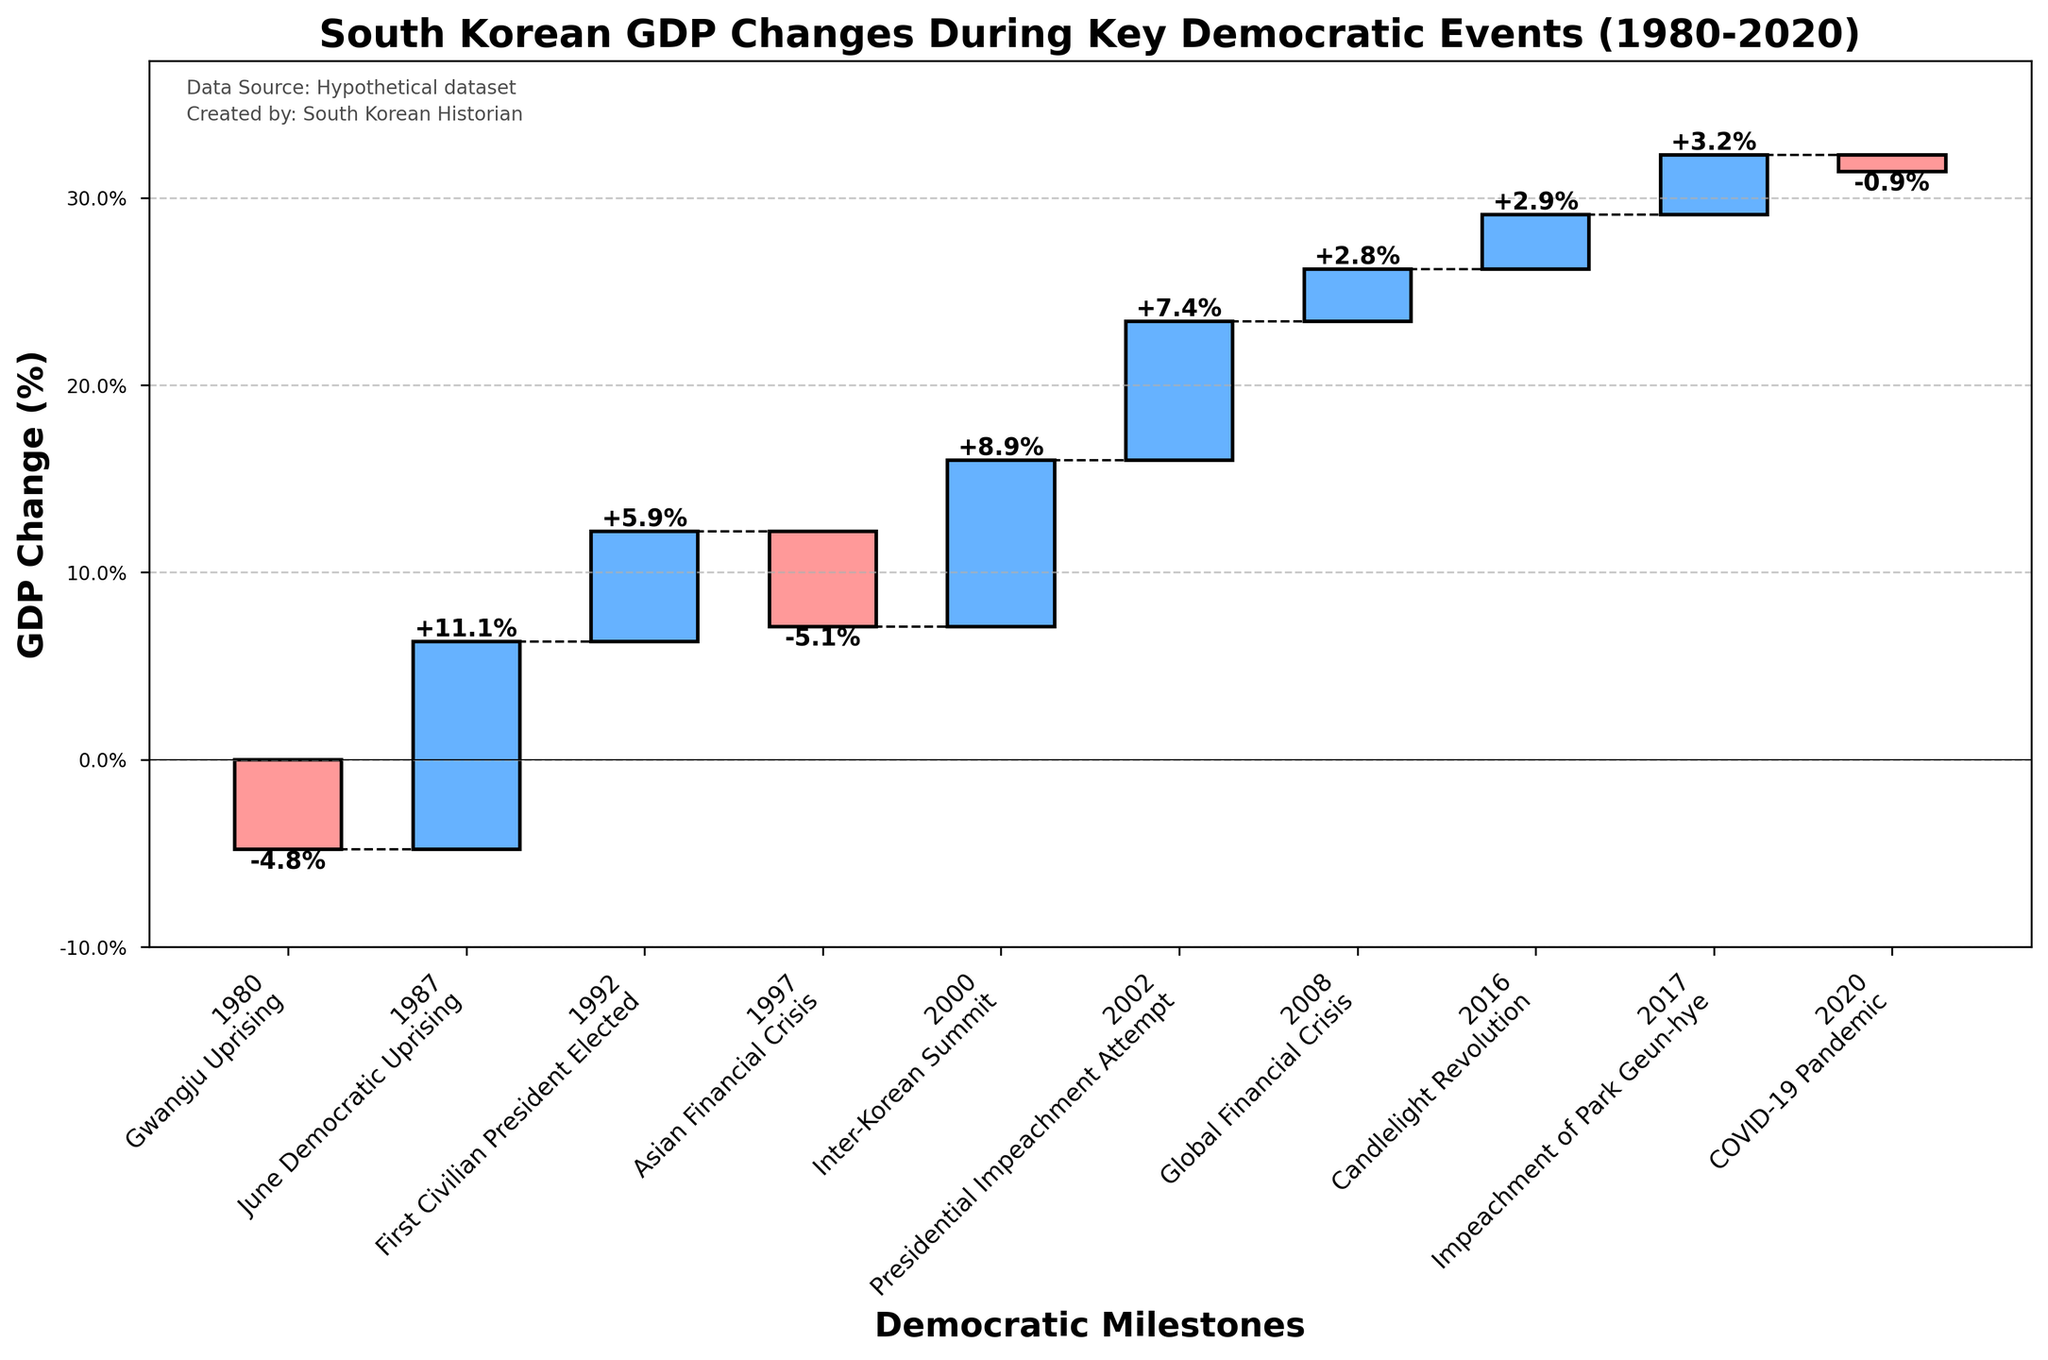What is the title of the figure? The title is located at the top of the figure and specifies what the chart represents. In this case, it reads "South Korean GDP Changes During Key Democratic Events (1980-2020)."
Answer: South Korean GDP Changes During Key Democratic Events (1980-2020) How many key democratic events are depicted in the figure? The number of bars in the chart corresponds to the number of events. Each bar represents a unique event, and by counting the bars, we can determine the number. There are 10 events shown.
Answer: 10 Which event resulted in the largest positive GDP change? By comparing the heights of the blue bars, the event with the largest positive change is the one with the tallest blue bar. The June Democratic Uprising in 1987 shows the highest positive change of 11.1%.
Answer: June Democratic Uprising, 1987 Which event resulted in the largest negative GDP change? By comparing the heights of the red bars, the event with the largest negative change is the one with the tallest red bar. The Asian Financial Crisis in 1997 shows the largest negative change of -5.1%.
Answer: Asian Financial Crisis, 1997 What was the cumulative GDP change by the year 2000? The cumulative GDP change is calculated by summing all preceding changes. By the year 2000, the cumulative change is (-4.8 + 11.1 + 5.9 - 5.1 + 8.9).
Answer: 16 How did the GDP change during the 2008 Global Financial Crisis compare to the 2020 COVID-19 Pandemic? To compare the changes, look at the heights of the bars for these two events. The 2008 Global Financial Crisis had a GDP change of 2.8%, while the 2020 COVID-19 Pandemic had a GDP change of -0.9%. The GDP increased during the 2008 crisis, whereas it decreased during the 2020 pandemic.
Answer: 2008: +2.8%, 2020: -0.9% What is the difference in GDP change between the first civilian president elected in 1992 and the Candlelight Revolution in 2016? Subtract the GDP change in 2016 from that in 1992. The values are 5.9% for 1992 and 2.9% for 2016. The difference is 5.9% - 2.9%.
Answer: 3.0% What is the average GDP change during the events in the 1990s? Identify the events in the 1990s (1992 and 1997) and average their GDP changes. The changes are 5.9% and -5.1%. Average = (5.9 + (-5.1))/2.
Answer: 0.4% Which events marked a negative GDP change? Identify and list the events with red bars. These events are the Gwangju Uprising (1980), Asian Financial Crisis (1997), and COVID-19 Pandemic (2020).
Answer: Gwangju Uprising, Asian Financial Crisis, COVID-19 Pandemic What was the cumulative GDP change by the end of 2020? Sum all the GDP changes from 1980 to 2020: -4.8, 11.1, 5.9, -5.1, 8.9, 7.4, 2.8, 2.9, 3.2, -0.9. The cumulative change equals 31.4 - 14.1.
Answer: 17.3 